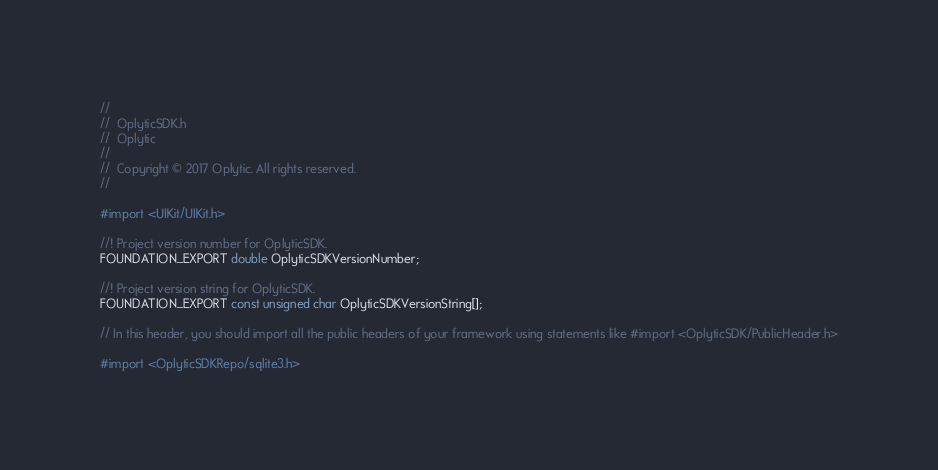<code> <loc_0><loc_0><loc_500><loc_500><_C_>//
//  OplyticSDK.h
//  Oplytic
//
//  Copyright © 2017 Oplytic. All rights reserved.
//

#import <UIKit/UIKit.h>

//! Project version number for OplyticSDK.
FOUNDATION_EXPORT double OplyticSDKVersionNumber;

//! Project version string for OplyticSDK.
FOUNDATION_EXPORT const unsigned char OplyticSDKVersionString[];

// In this header, you should import all the public headers of your framework using statements like #import <OplyticSDK/PublicHeader.h>

#import <OplyticSDKRepo/sqlite3.h>

</code> 